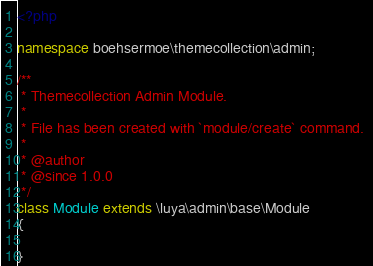<code> <loc_0><loc_0><loc_500><loc_500><_PHP_><?php

namespace boehsermoe\themecollection\admin;

/**
 * Themecollection Admin Module.
 *
 * File has been created with `module/create` command. 
 * 
 * @author
 * @since 1.0.0
 */
class Module extends \luya\admin\base\Module
{

}</code> 